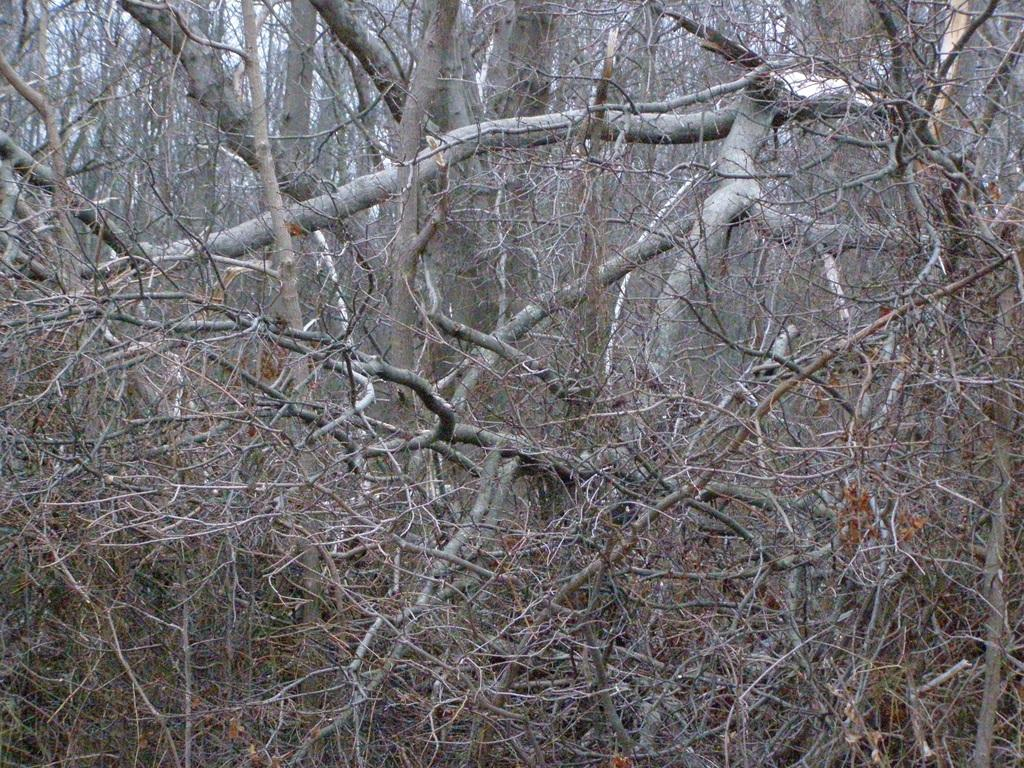What is the main subject of the image? The main subject of the image is a fallen tree. Can you describe the fallen tree in the image? The fallen tree is brown and grey in color. What can be seen in the background of the image? There are trees and the sky visible in the background of the image. What type of pleasure can be seen enjoying the fallen tree in the image? There is no indication of pleasure or any living beings in the image; it only features a fallen tree. Can you see a balloon tied to the fallen tree in the image? There is no balloon present in the image; it only features a fallen tree. 